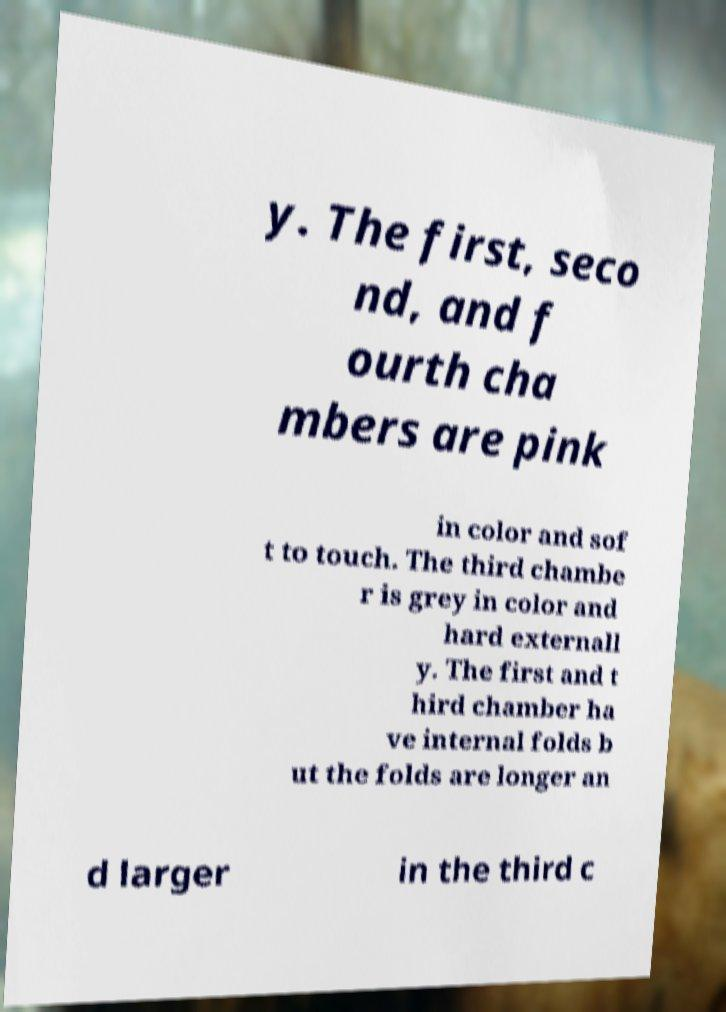There's text embedded in this image that I need extracted. Can you transcribe it verbatim? y. The first, seco nd, and f ourth cha mbers are pink in color and sof t to touch. The third chambe r is grey in color and hard externall y. The first and t hird chamber ha ve internal folds b ut the folds are longer an d larger in the third c 